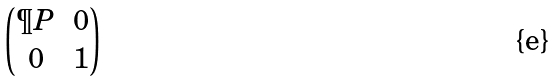<formula> <loc_0><loc_0><loc_500><loc_500>\begin{pmatrix} \P P & 0 \\ 0 & 1 \end{pmatrix}</formula> 